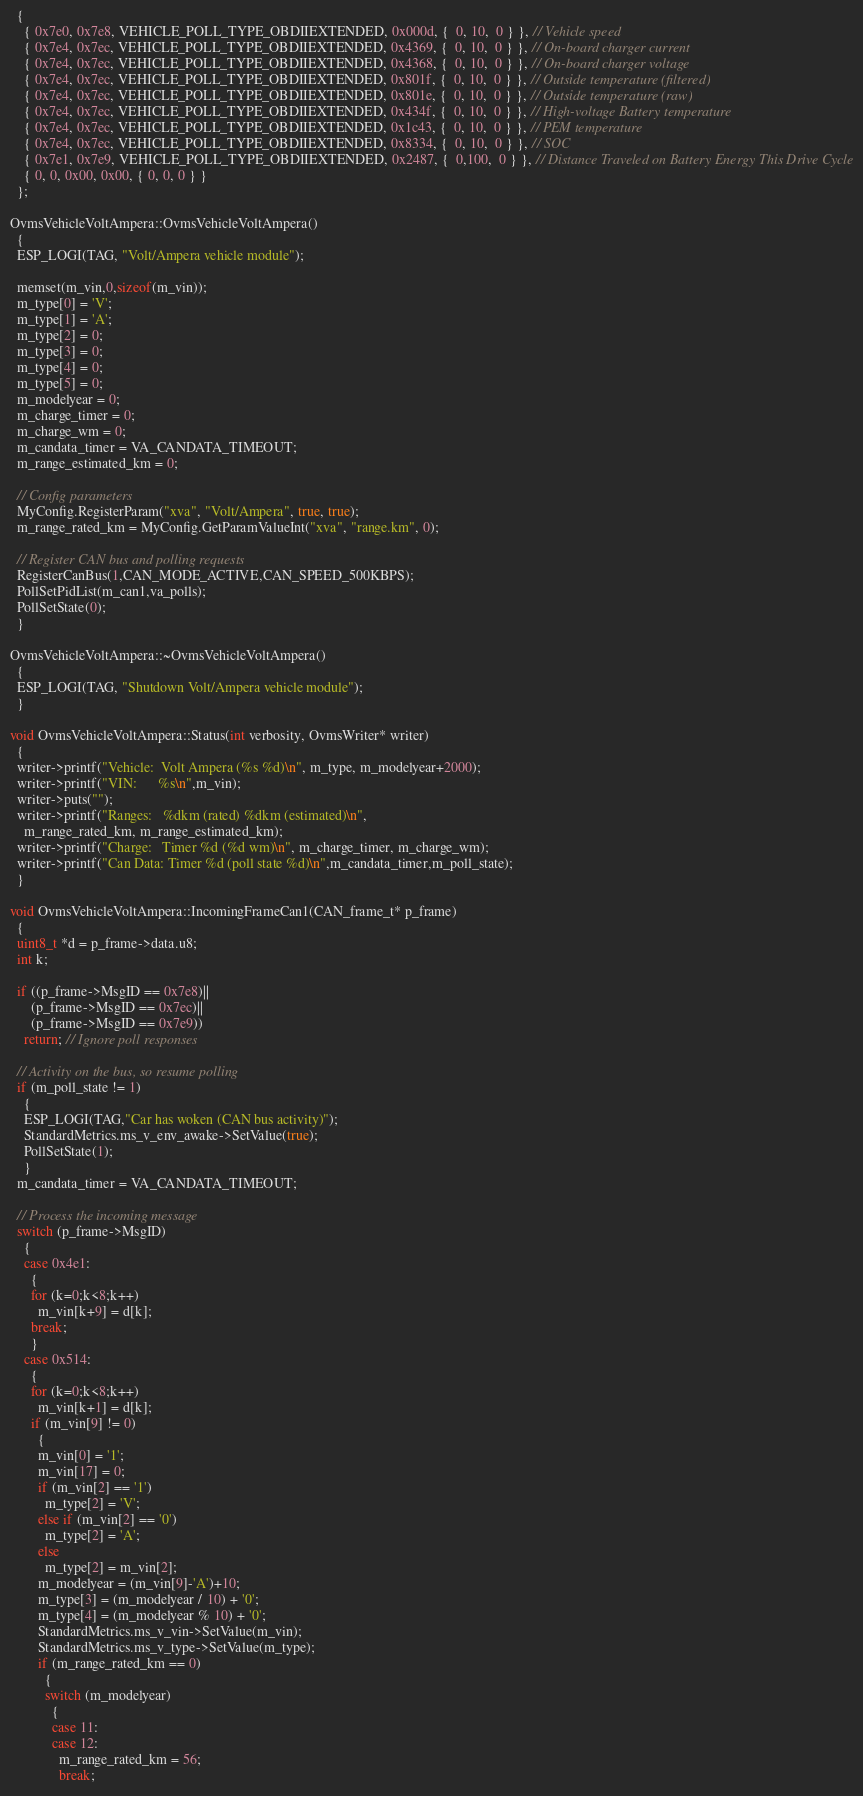Convert code to text. <code><loc_0><loc_0><loc_500><loc_500><_C++_>  {
    { 0x7e0, 0x7e8, VEHICLE_POLL_TYPE_OBDIIEXTENDED, 0x000d, {  0, 10,  0 } }, // Vehicle speed
    { 0x7e4, 0x7ec, VEHICLE_POLL_TYPE_OBDIIEXTENDED, 0x4369, {  0, 10,  0 } }, // On-board charger current
    { 0x7e4, 0x7ec, VEHICLE_POLL_TYPE_OBDIIEXTENDED, 0x4368, {  0, 10,  0 } }, // On-board charger voltage
    { 0x7e4, 0x7ec, VEHICLE_POLL_TYPE_OBDIIEXTENDED, 0x801f, {  0, 10,  0 } }, // Outside temperature (filtered)
    { 0x7e4, 0x7ec, VEHICLE_POLL_TYPE_OBDIIEXTENDED, 0x801e, {  0, 10,  0 } }, // Outside temperature (raw)
    { 0x7e4, 0x7ec, VEHICLE_POLL_TYPE_OBDIIEXTENDED, 0x434f, {  0, 10,  0 } }, // High-voltage Battery temperature
    { 0x7e4, 0x7ec, VEHICLE_POLL_TYPE_OBDIIEXTENDED, 0x1c43, {  0, 10,  0 } }, // PEM temperature
    { 0x7e4, 0x7ec, VEHICLE_POLL_TYPE_OBDIIEXTENDED, 0x8334, {  0, 10,  0 } }, // SOC
    { 0x7e1, 0x7e9, VEHICLE_POLL_TYPE_OBDIIEXTENDED, 0x2487, {  0,100,  0 } }, // Distance Traveled on Battery Energy This Drive Cycle
    { 0, 0, 0x00, 0x00, { 0, 0, 0 } }
  };

OvmsVehicleVoltAmpera::OvmsVehicleVoltAmpera()
  {
  ESP_LOGI(TAG, "Volt/Ampera vehicle module");

  memset(m_vin,0,sizeof(m_vin));
  m_type[0] = 'V';
  m_type[1] = 'A';
  m_type[2] = 0;
  m_type[3] = 0;
  m_type[4] = 0;
  m_type[5] = 0;
  m_modelyear = 0;
  m_charge_timer = 0;
  m_charge_wm = 0;
  m_candata_timer = VA_CANDATA_TIMEOUT;
  m_range_estimated_km = 0;

  // Config parameters
  MyConfig.RegisterParam("xva", "Volt/Ampera", true, true);
  m_range_rated_km = MyConfig.GetParamValueInt("xva", "range.km", 0);

  // Register CAN bus and polling requests
  RegisterCanBus(1,CAN_MODE_ACTIVE,CAN_SPEED_500KBPS);
  PollSetPidList(m_can1,va_polls);
  PollSetState(0);
  }

OvmsVehicleVoltAmpera::~OvmsVehicleVoltAmpera()
  {
  ESP_LOGI(TAG, "Shutdown Volt/Ampera vehicle module");
  }

void OvmsVehicleVoltAmpera::Status(int verbosity, OvmsWriter* writer)
  {
  writer->printf("Vehicle:  Volt Ampera (%s %d)\n", m_type, m_modelyear+2000);
  writer->printf("VIN:      %s\n",m_vin);
  writer->puts("");
  writer->printf("Ranges:   %dkm (rated) %dkm (estimated)\n",
    m_range_rated_km, m_range_estimated_km);
  writer->printf("Charge:   Timer %d (%d wm)\n", m_charge_timer, m_charge_wm);
  writer->printf("Can Data: Timer %d (poll state %d)\n",m_candata_timer,m_poll_state);
  }

void OvmsVehicleVoltAmpera::IncomingFrameCan1(CAN_frame_t* p_frame)
  {
  uint8_t *d = p_frame->data.u8;
  int k;

  if ((p_frame->MsgID == 0x7e8)||
      (p_frame->MsgID == 0x7ec)||
      (p_frame->MsgID == 0x7e9))
    return; // Ignore poll responses

  // Activity on the bus, so resume polling
  if (m_poll_state != 1)
    {
    ESP_LOGI(TAG,"Car has woken (CAN bus activity)");
    StandardMetrics.ms_v_env_awake->SetValue(true);
    PollSetState(1);
    }
  m_candata_timer = VA_CANDATA_TIMEOUT;

  // Process the incoming message
  switch (p_frame->MsgID)
    {
    case 0x4e1:
      {
      for (k=0;k<8;k++)
        m_vin[k+9] = d[k];
      break;
      }
    case 0x514:
      {
      for (k=0;k<8;k++)
        m_vin[k+1] = d[k];
      if (m_vin[9] != 0)
        {
        m_vin[0] = '1';
        m_vin[17] = 0;
        if (m_vin[2] == '1')
          m_type[2] = 'V';
        else if (m_vin[2] == '0')
          m_type[2] = 'A';
        else
          m_type[2] = m_vin[2];
        m_modelyear = (m_vin[9]-'A')+10;
        m_type[3] = (m_modelyear / 10) + '0';
        m_type[4] = (m_modelyear % 10) + '0';
        StandardMetrics.ms_v_vin->SetValue(m_vin);
        StandardMetrics.ms_v_type->SetValue(m_type);
        if (m_range_rated_km == 0)
          {
          switch (m_modelyear)
            {
            case 11:
            case 12:
              m_range_rated_km = 56;
              break;</code> 